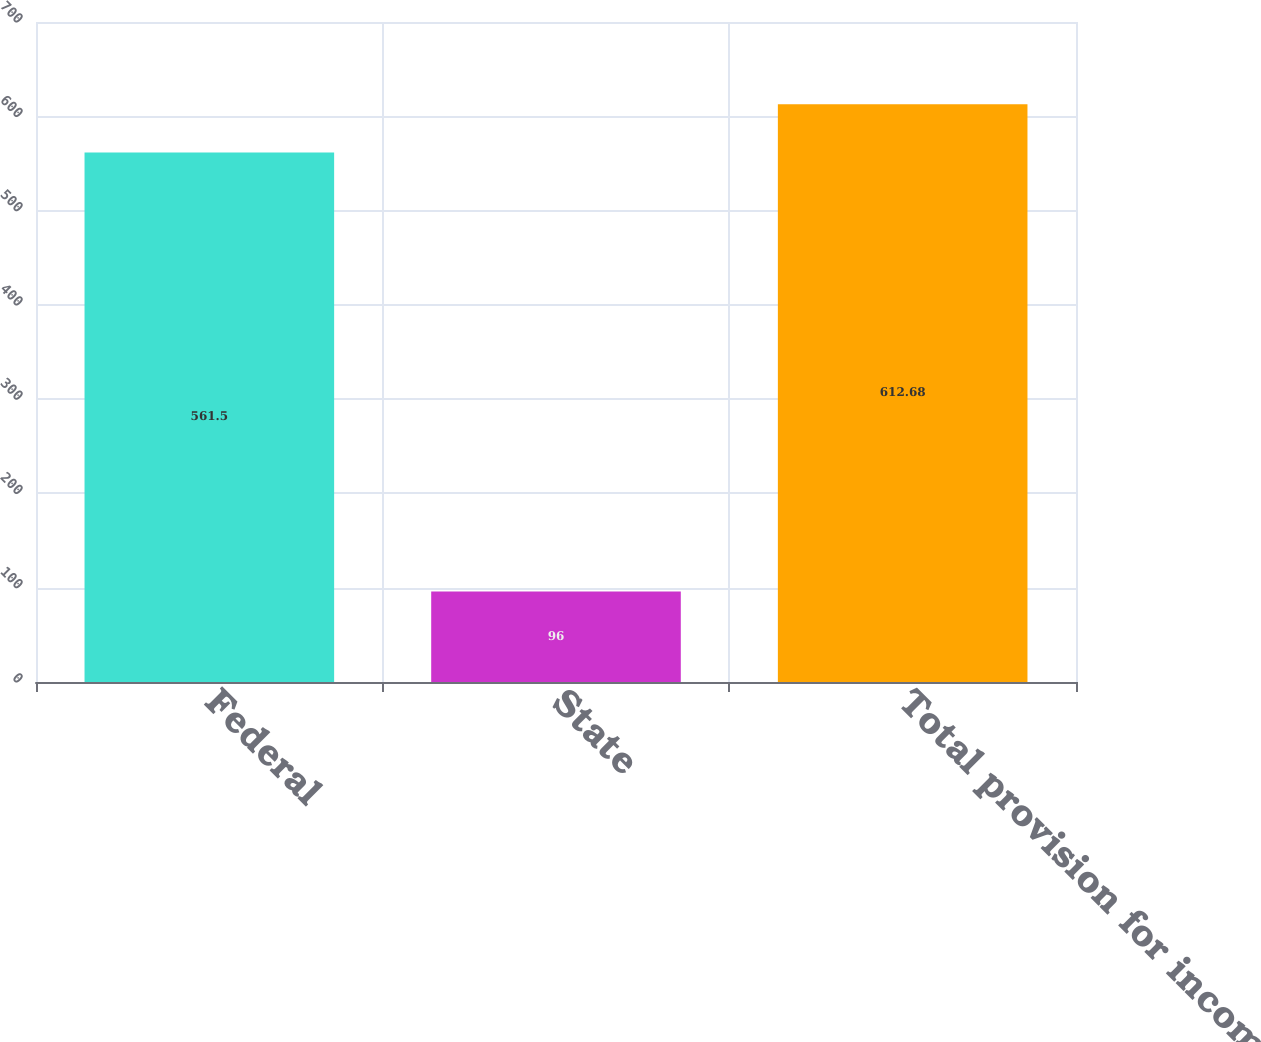<chart> <loc_0><loc_0><loc_500><loc_500><bar_chart><fcel>Federal<fcel>State<fcel>Total provision for income<nl><fcel>561.5<fcel>96<fcel>612.68<nl></chart> 